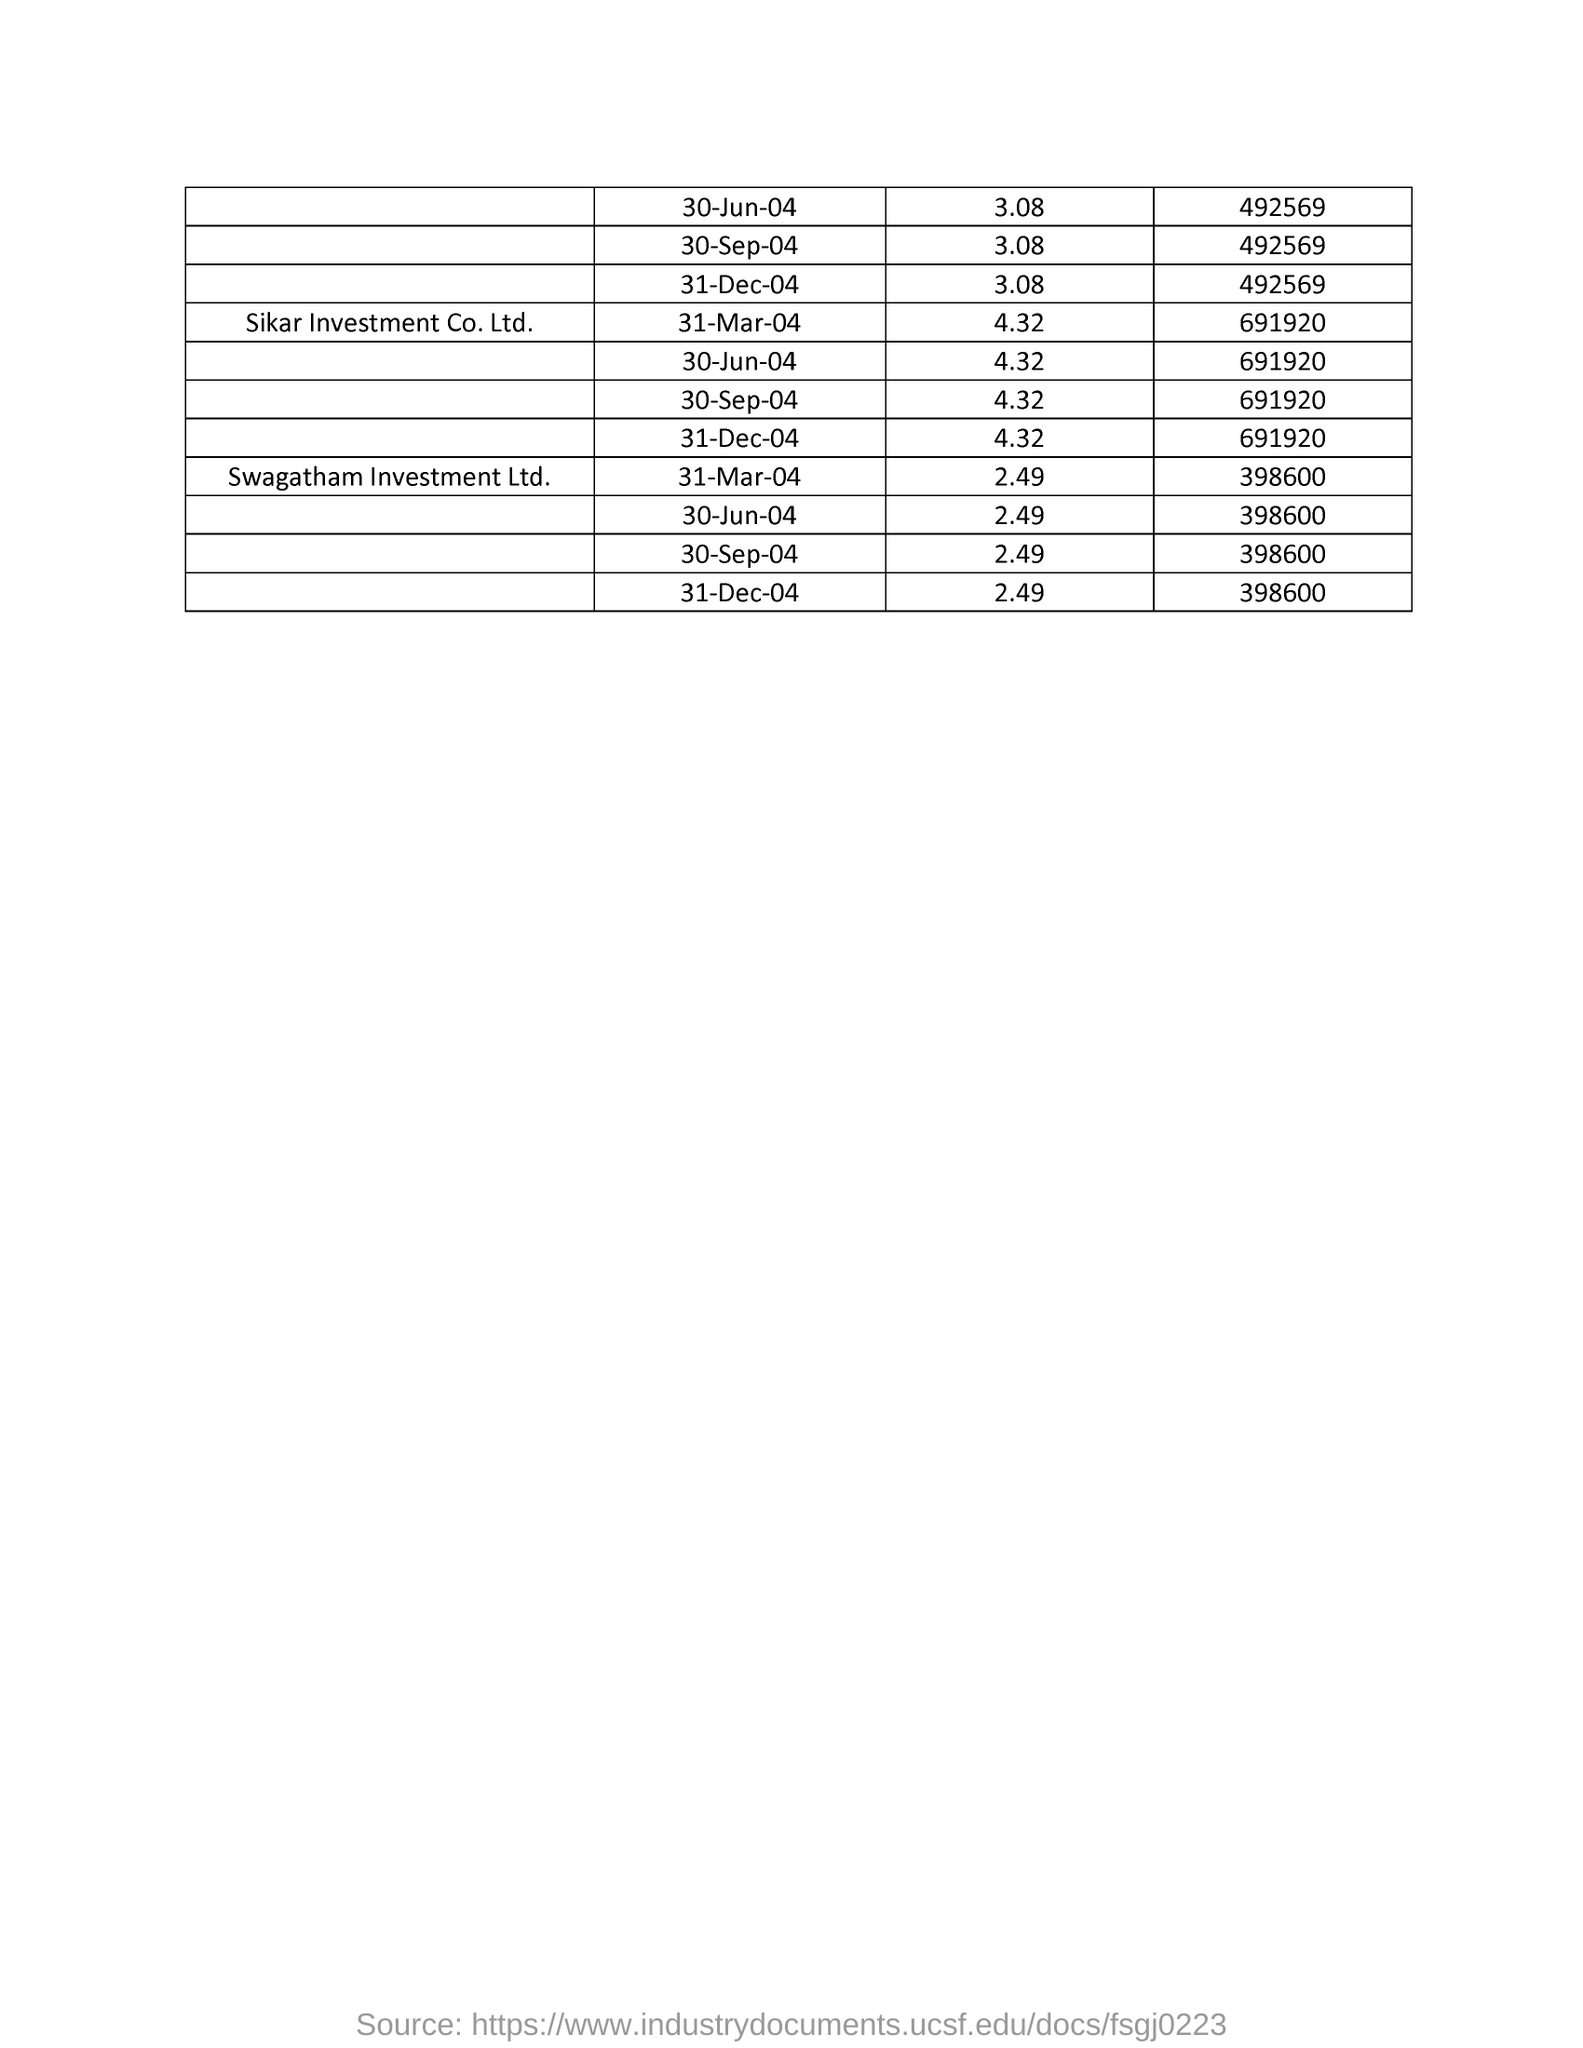What is the first company in the list ?
Provide a short and direct response. Sikar Investment Co. Ltd. 